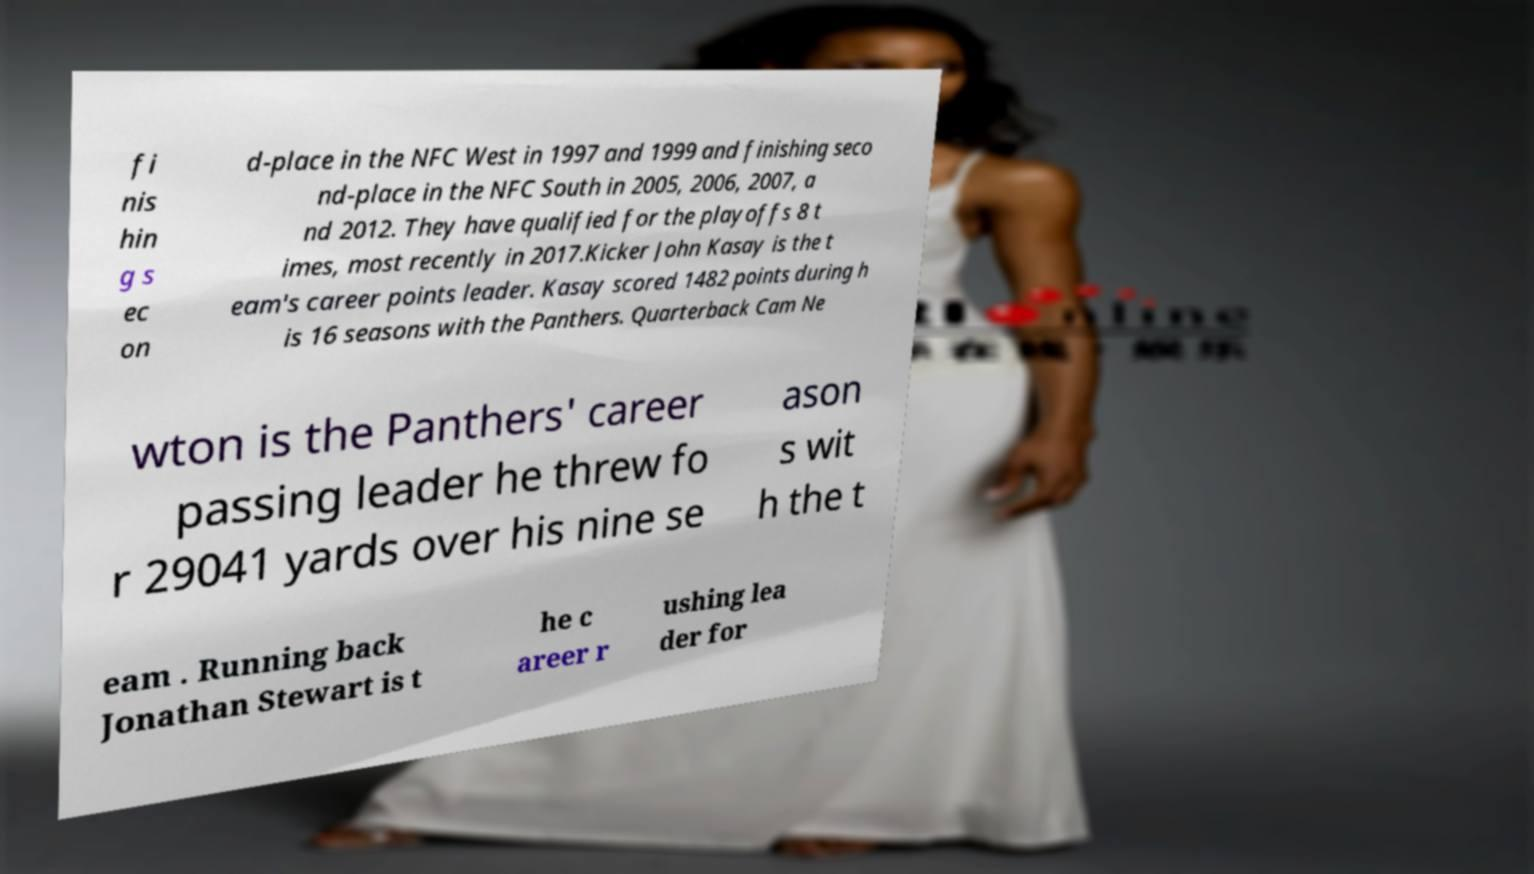Could you extract and type out the text from this image? fi nis hin g s ec on d-place in the NFC West in 1997 and 1999 and finishing seco nd-place in the NFC South in 2005, 2006, 2007, a nd 2012. They have qualified for the playoffs 8 t imes, most recently in 2017.Kicker John Kasay is the t eam's career points leader. Kasay scored 1482 points during h is 16 seasons with the Panthers. Quarterback Cam Ne wton is the Panthers' career passing leader he threw fo r 29041 yards over his nine se ason s wit h the t eam . Running back Jonathan Stewart is t he c areer r ushing lea der for 